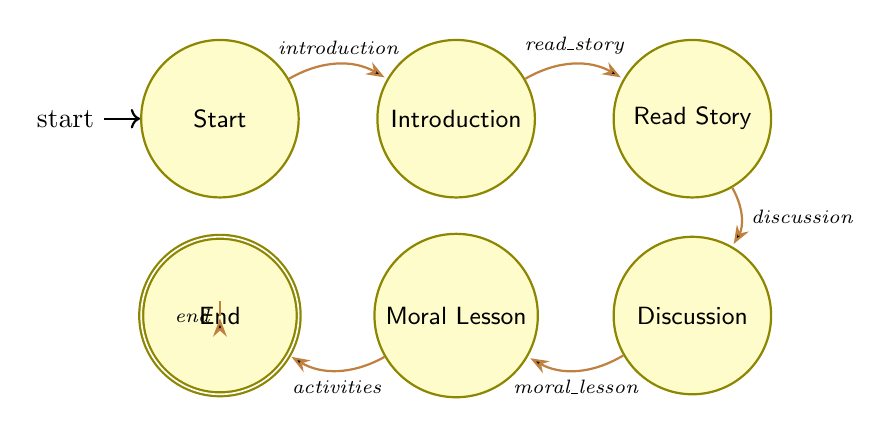What's the initial state of the teaching session? The diagram starts with the "Start" node, which represents the beginning of the teaching session.
Answer: Start How many states are present in the diagram? By counting each labeled node in the diagram, we find that there are six states: Start, Introduction, ReadStory, Discussion, MoralLesson, and Activities.
Answer: Six What happens after the "Discussion" state? From the diagram, the transition from the "Discussion" state leads to the "MoralLesson" state when the trigger "moral_lesson" occurs.
Answer: MoralLesson What actions are associated with the "Activities" state? The "Activities" state includes three actions: Craft activities, Role-playing the story, and Memory verses, all of which aim to reinforce the learning experience.
Answer: Craft activities, Role-playing the story, Memory verses Which state follows the "ReadStory" state? The transition from the "ReadStory" state goes to the "Discussion" state when the trigger "discussion" is activated.
Answer: Discussion How does the diagram conclude the teaching session? The diagram concludes with the "End" state, where actions include summarizing key points, giving take-home materials, and encouraging family discussions, indicating a wrap-up of the session.
Answer: End What is the purpose of the "Introduction" state? The "Introduction" state serves to introduce the story and explain its importance, providing context before engaging with the story itself.
Answer: Introduce the story, Explain the purpose Which state allows children to express their thoughts? The "Discussion" state is where children are encouraged to express their thoughts and share their perspectives on the story that was read.
Answer: Discussion 